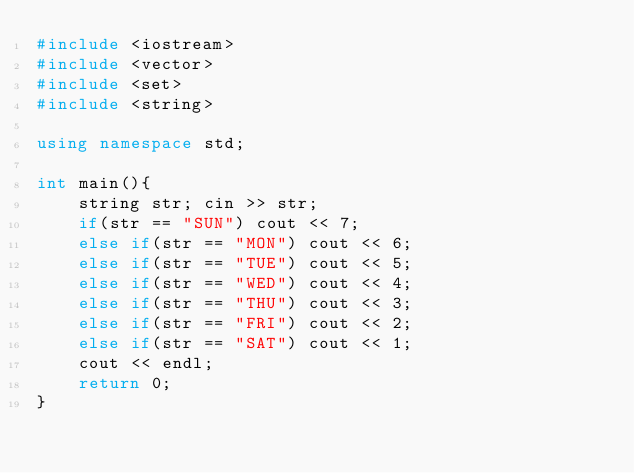<code> <loc_0><loc_0><loc_500><loc_500><_C++_>#include <iostream>
#include <vector>
#include <set>
#include <string>

using namespace std;

int main(){
    string str; cin >> str;
    if(str == "SUN") cout << 7;
    else if(str == "MON") cout << 6;
    else if(str == "TUE") cout << 5;
    else if(str == "WED") cout << 4;
    else if(str == "THU") cout << 3;
    else if(str == "FRI") cout << 2;
    else if(str == "SAT") cout << 1;
    cout << endl;
    return 0;
}</code> 